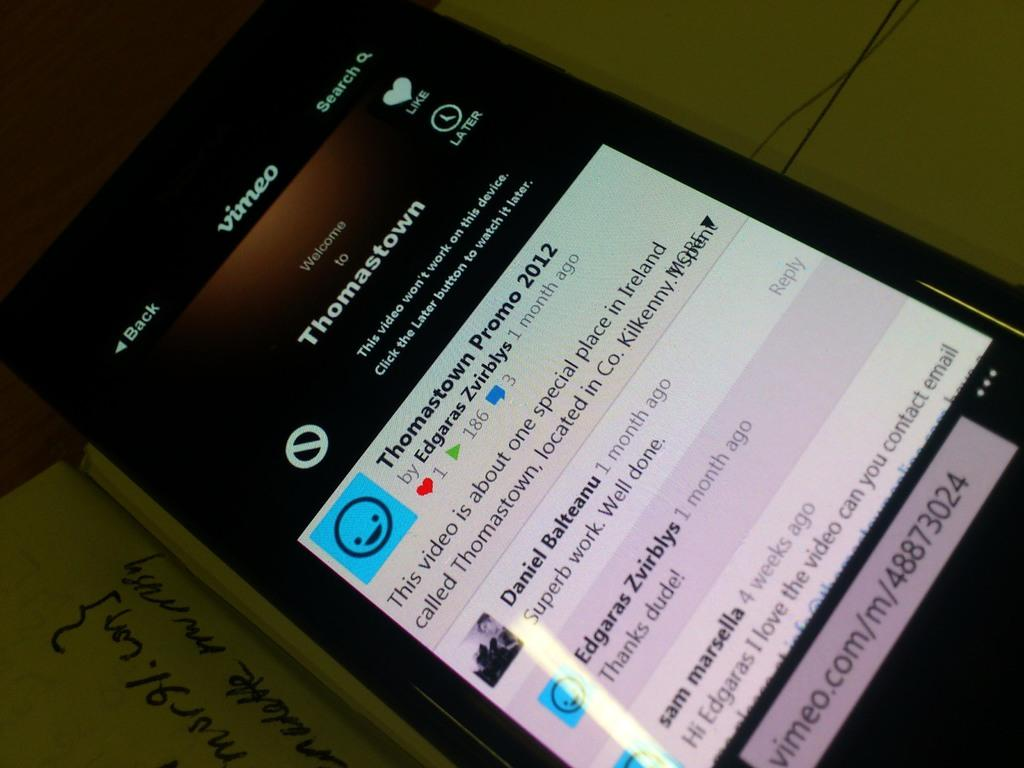<image>
Give a short and clear explanation of the subsequent image. Black phone showing a Thomastown Promo 2012 on the screen. 